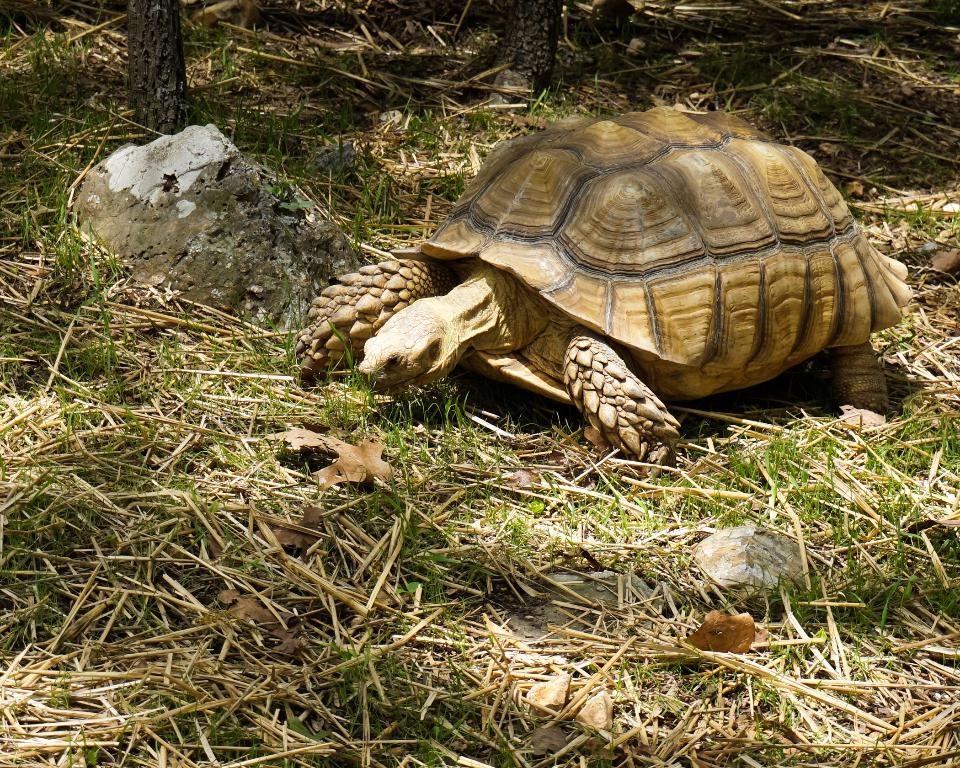What type of animal is in the image? There is a tortoise in the image. What else can be seen in the image besides the tortoise? There are stones and grass in the image. Can you describe the type of grass in the image? There is dry grass in the image. What type of soda is the tortoise drinking in the image? There is no soda present in the image; it only features a tortoise, stones, and grass. 